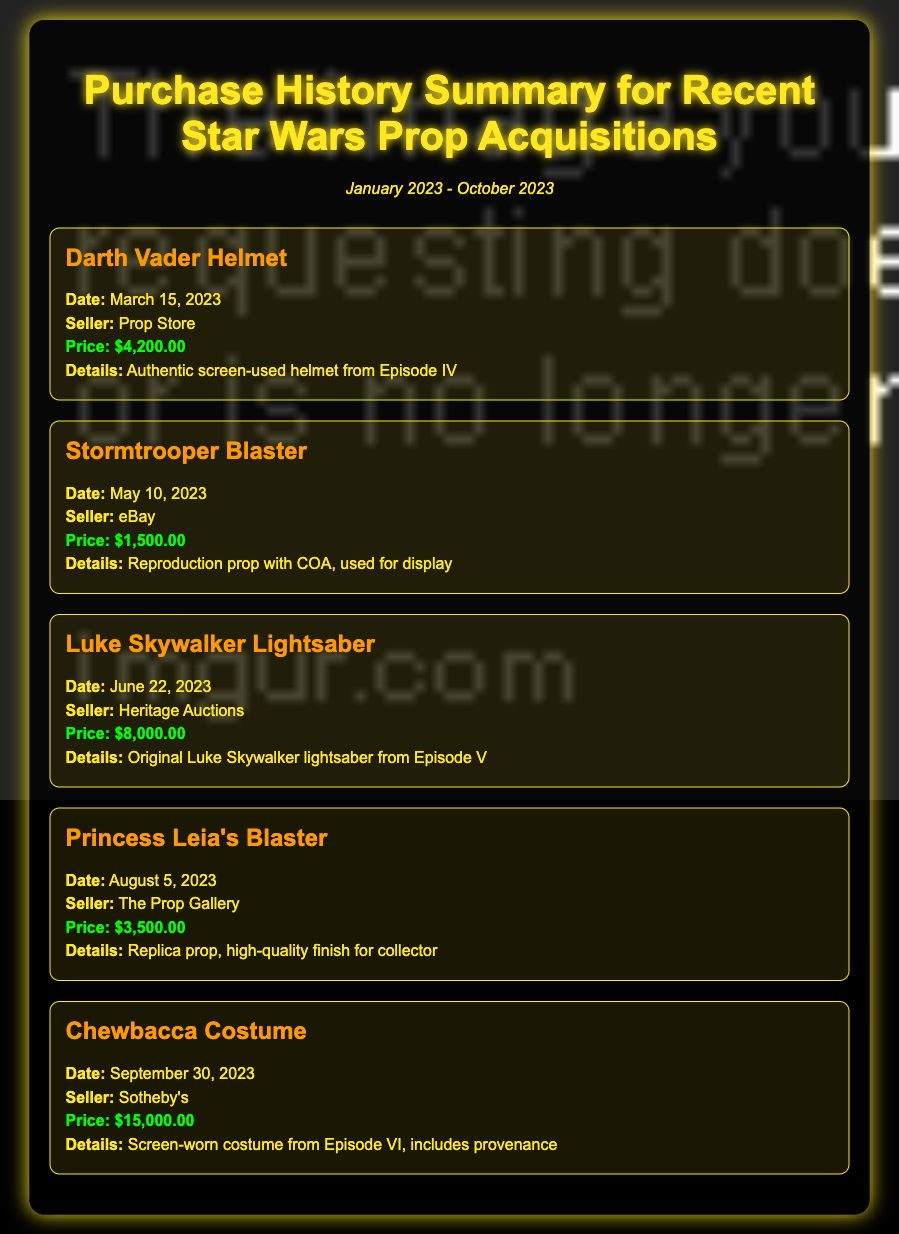What is the total number of props listed? The document lists five different prop acquisitions.
Answer: 5 What was the price of the Luke Skywalker Lightsaber? The price listed for the Luke Skywalker Lightsaber is $8,000.00.
Answer: $8,000.00 When was the Chewbacca Costume acquired? The document shows that the Chewbacca Costume was acquired on September 30, 2023.
Answer: September 30, 2023 Who sold the Stormtrooper Blaster? The Stormtrooper Blaster was sold by eBay.
Answer: eBay Which acquisition had the highest price? The Chewbacca Costume is noted as the acquisition with the highest price at $15,000.00.
Answer: $15,000.00 What type of prop is Princess Leia's Blaster? The document specifies that Princess Leia's Blaster is a replica prop.
Answer: Replica prop How many items were acquired in August 2023? Only one item, Princess Leia's Blaster, was acquired in August 2023.
Answer: 1 Who sold the Darth Vader Helmet? The seller of the Darth Vader Helmet is Prop Store.
Answer: Prop Store What notable detail is mentioned for the Chewbacca Costume? The Chewbacca Costume includes provenance, detailing its history.
Answer: Provenance 